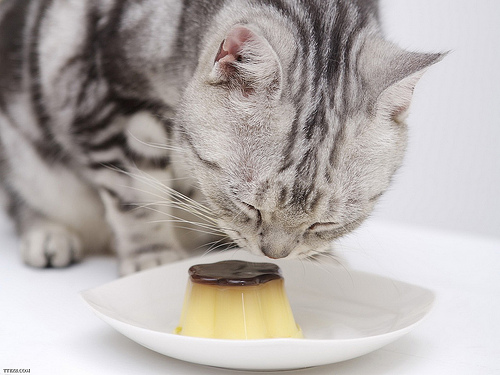Please provide the bounding box coordinate of the region this sentence describes: the cat ear is pink. [0.4, 0.17, 0.57, 0.32] Please provide a short description for this region: [0.61, 0.54, 0.69, 0.61]. A left cat eye. Please provide the bounding box coordinate of the region this sentence describes: two cat ears. [0.42, 0.16, 0.9, 0.36] Please provide the bounding box coordinate of the region this sentence describes: stripes on the cat. [0.53, 0.12, 0.74, 0.54] Please provide the bounding box coordinate of the region this sentence describes: brown top on custard. [0.37, 0.64, 0.55, 0.74] Please provide a short description for this region: [0.35, 0.65, 0.63, 0.79]. A pudding in the saucer. Please provide the bounding box coordinate of the region this sentence describes: cat's tail curled around it's leg. [0.0, 0.35, 0.24, 0.63] Please provide a short description for this region: [0.31, 0.57, 0.61, 0.81]. Small custard on plate. Please provide a short description for this region: [0.33, 0.71, 0.57, 0.82]. Off white base on custard. Please provide a short description for this region: [0.23, 0.45, 0.38, 0.68]. A right cat paw. 